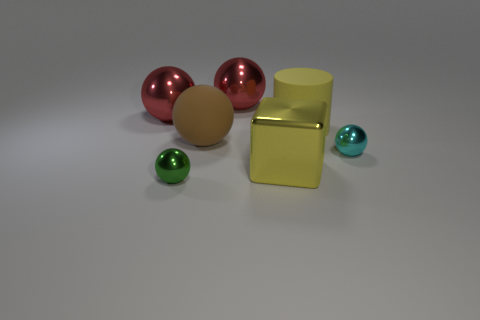Subtract all red spheres. How many spheres are left? 3 Add 3 yellow cylinders. How many objects exist? 10 Subtract all brown spheres. How many spheres are left? 4 Subtract 1 balls. How many balls are left? 4 Add 2 large cyan metallic things. How many large cyan metallic things exist? 2 Subtract 0 red cylinders. How many objects are left? 7 Subtract all cubes. How many objects are left? 6 Subtract all green cylinders. Subtract all brown spheres. How many cylinders are left? 1 Subtract all blue cylinders. How many red blocks are left? 0 Subtract all large cyan blocks. Subtract all metal objects. How many objects are left? 2 